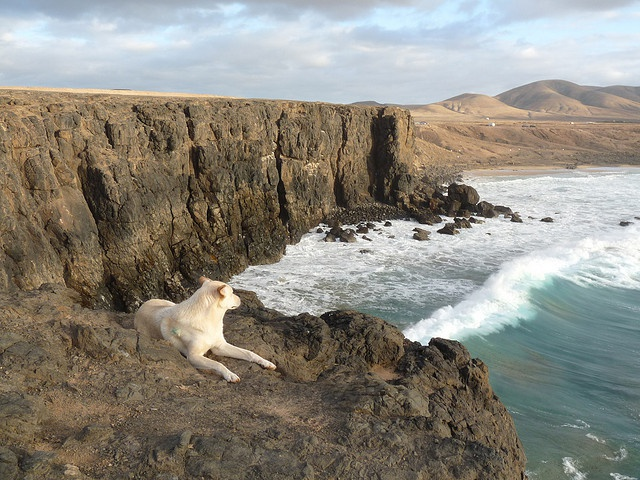Describe the objects in this image and their specific colors. I can see a dog in darkgray, beige, and tan tones in this image. 